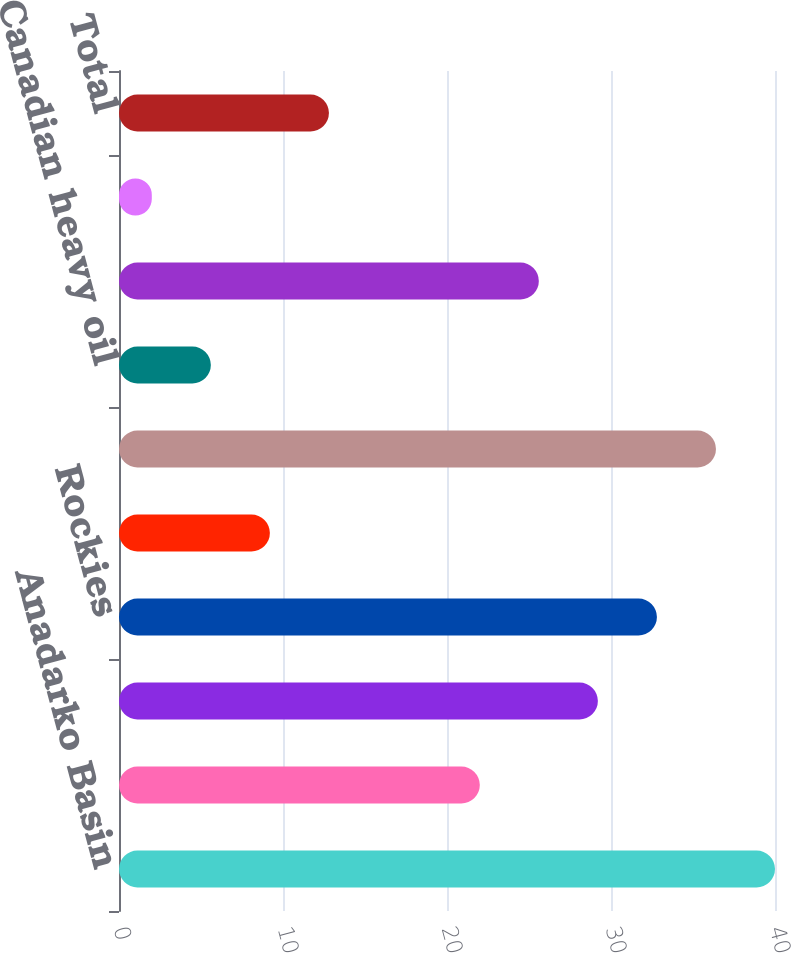Convert chart. <chart><loc_0><loc_0><loc_500><loc_500><bar_chart><fcel>Anadarko Basin<fcel>Barnett Shale<fcel>Permian Basin<fcel>Rockies<fcel>Other<fcel>US core and emerging<fcel>Canadian heavy oil<fcel>Total core and emerging<fcel>Non-core properties<fcel>Total<nl><fcel>40<fcel>22<fcel>29.2<fcel>32.8<fcel>9.2<fcel>36.4<fcel>5.6<fcel>25.6<fcel>2<fcel>12.8<nl></chart> 